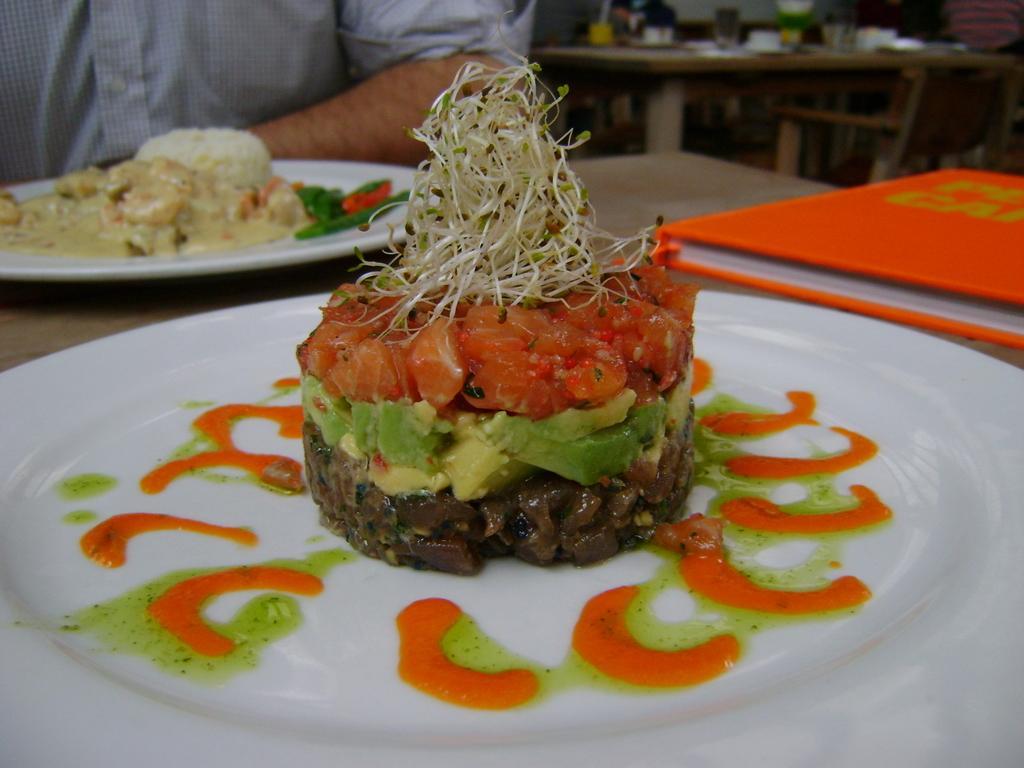Please provide a concise description of this image. In the center of the image we can see a table. On the table we can see a bookplates which contain food items. At the top of the image we can see a man is sitting and also we can see a chair, table. On the table we can see the bottles, glass, papers and some other objects. 